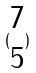Convert formula to latex. <formula><loc_0><loc_0><loc_500><loc_500>( \begin{matrix} 7 \\ 5 \end{matrix} )</formula> 